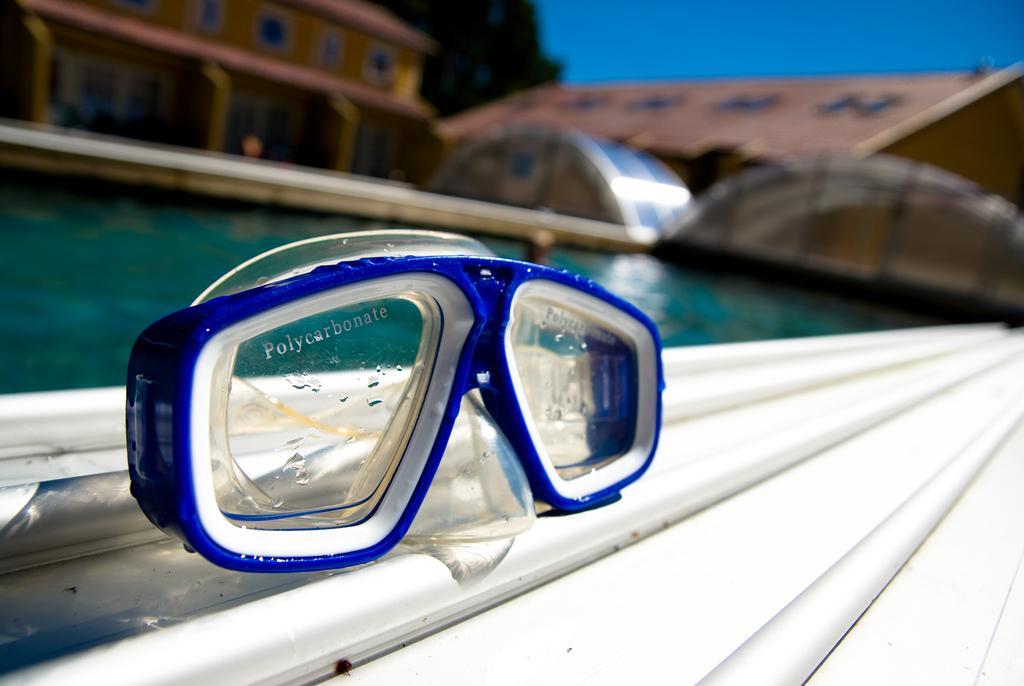Could you give a brief overview of what you see in this image? Here in this picture we can see swimming goggles present over a place and behind that we can see a pool filled with water and we can see everything in blurry manner. 